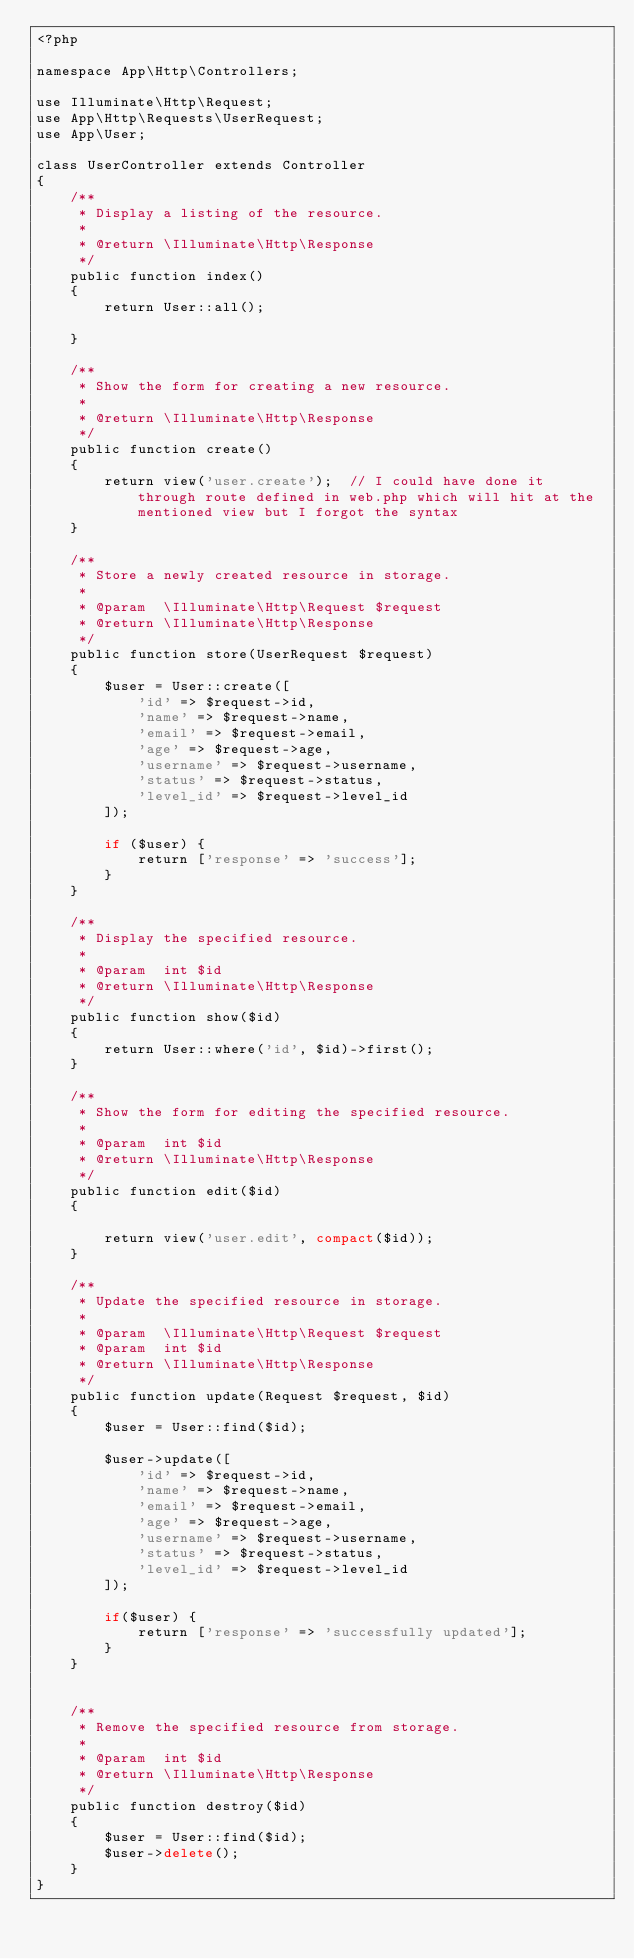<code> <loc_0><loc_0><loc_500><loc_500><_PHP_><?php

namespace App\Http\Controllers;

use Illuminate\Http\Request;
use App\Http\Requests\UserRequest;
use App\User;

class UserController extends Controller
{
    /**
     * Display a listing of the resource.
     *
     * @return \Illuminate\Http\Response
     */
    public function index()
    {
        return User::all();

    }

    /**
     * Show the form for creating a new resource.
     *
     * @return \Illuminate\Http\Response
     */
    public function create()
    {
        return view('user.create');  // I could have done it through route defined in web.php which will hit at the mentioned view but I forgot the syntax
    }

    /**
     * Store a newly created resource in storage.
     *
     * @param  \Illuminate\Http\Request $request
     * @return \Illuminate\Http\Response
     */
    public function store(UserRequest $request)
    {
        $user = User::create([
            'id' => $request->id,
            'name' => $request->name,
            'email' => $request->email,
            'age' => $request->age,
            'username' => $request->username,
            'status' => $request->status,
            'level_id' => $request->level_id
        ]);

        if ($user) {
            return ['response' => 'success'];
        }
    }

    /**
     * Display the specified resource.
     *
     * @param  int $id
     * @return \Illuminate\Http\Response
     */
    public function show($id)
    {
        return User::where('id', $id)->first();
    }

    /**
     * Show the form for editing the specified resource.
     *
     * @param  int $id
     * @return \Illuminate\Http\Response
     */
    public function edit($id)
    {

        return view('user.edit', compact($id));
    }

    /**
     * Update the specified resource in storage.
     *
     * @param  \Illuminate\Http\Request $request
     * @param  int $id
     * @return \Illuminate\Http\Response
     */
    public function update(Request $request, $id)
    {
        $user = User::find($id);

        $user->update([
            'id' => $request->id,
            'name' => $request->name,
            'email' => $request->email,
            'age' => $request->age,
            'username' => $request->username,
            'status' => $request->status,
            'level_id' => $request->level_id
        ]);

        if($user) {
            return ['response' => 'successfully updated'];
        }
    }


    /**
     * Remove the specified resource from storage.
     *
     * @param  int $id
     * @return \Illuminate\Http\Response
     */
    public function destroy($id)
    {
        $user = User::find($id);
        $user->delete();
    }
}
</code> 